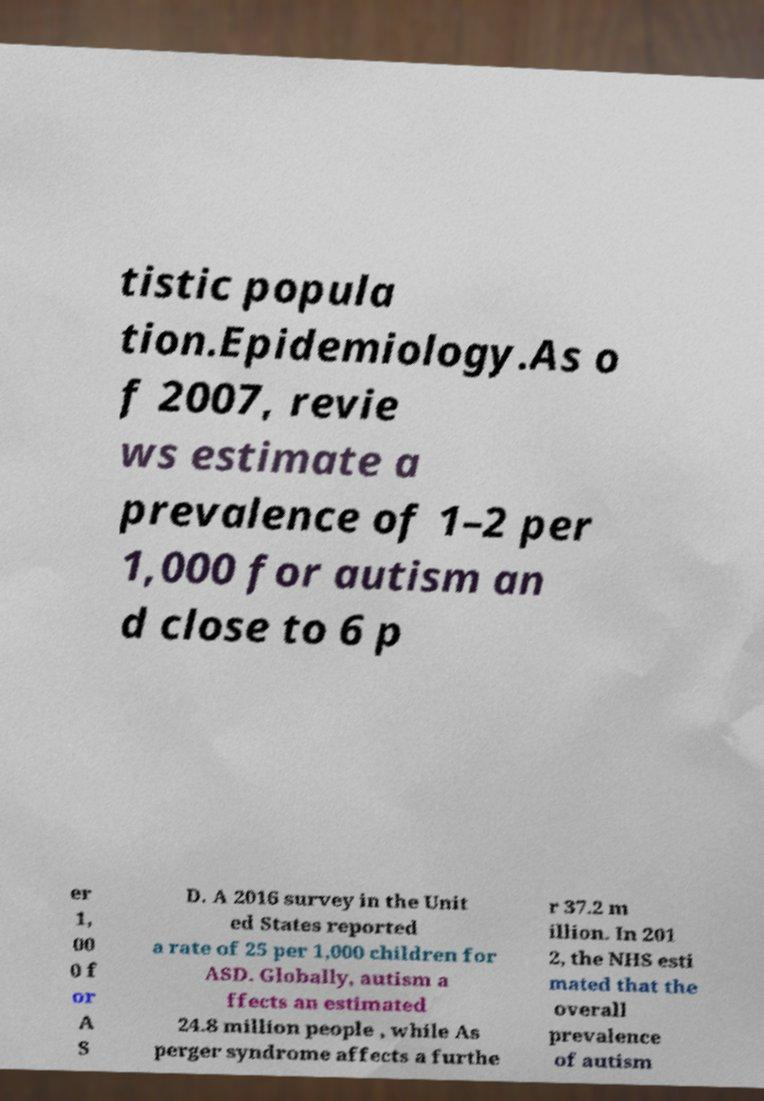There's text embedded in this image that I need extracted. Can you transcribe it verbatim? tistic popula tion.Epidemiology.As o f 2007, revie ws estimate a prevalence of 1–2 per 1,000 for autism an d close to 6 p er 1, 00 0 f or A S D. A 2016 survey in the Unit ed States reported a rate of 25 per 1,000 children for ASD. Globally, autism a ffects an estimated 24.8 million people , while As perger syndrome affects a furthe r 37.2 m illion. In 201 2, the NHS esti mated that the overall prevalence of autism 